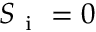Convert formula to latex. <formula><loc_0><loc_0><loc_500><loc_500>S _ { i } = 0</formula> 